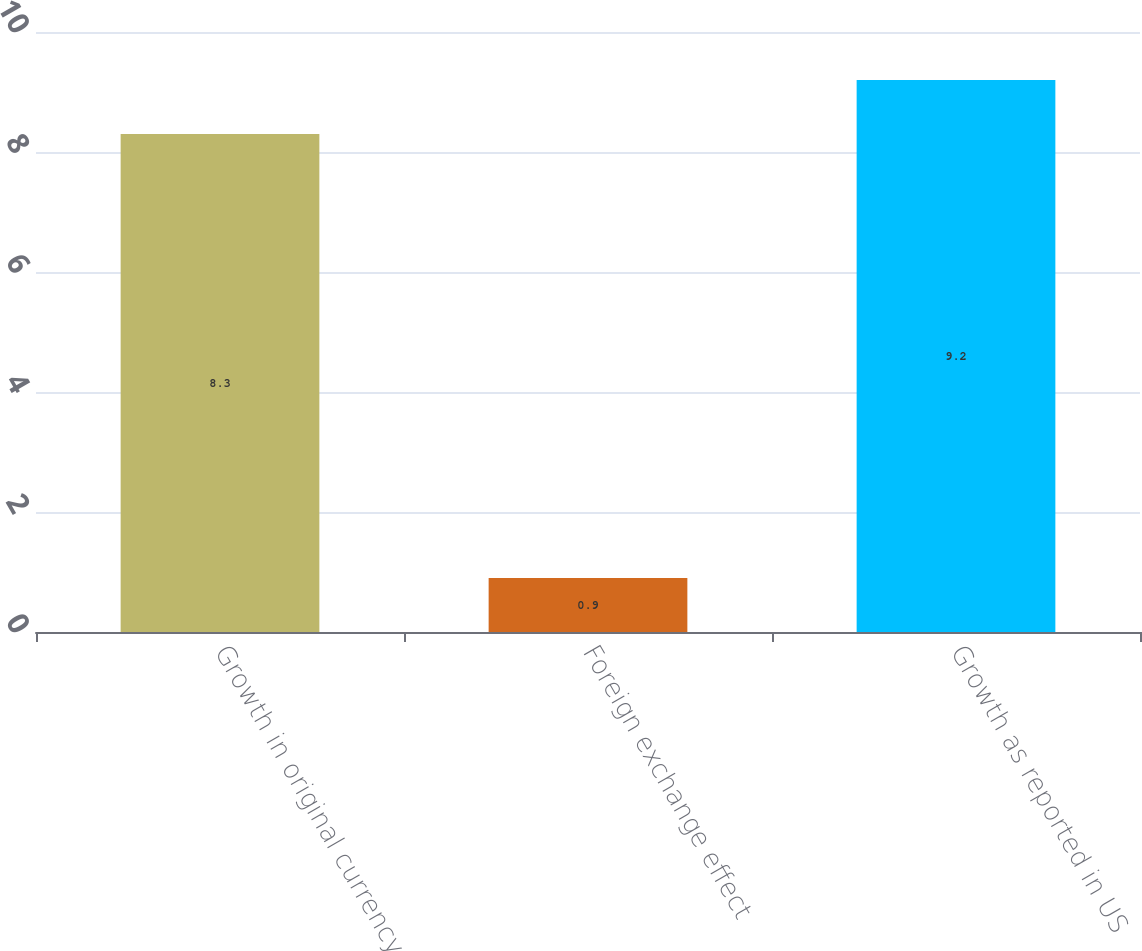<chart> <loc_0><loc_0><loc_500><loc_500><bar_chart><fcel>Growth in original currency<fcel>Foreign exchange effect<fcel>Growth as reported in US<nl><fcel>8.3<fcel>0.9<fcel>9.2<nl></chart> 